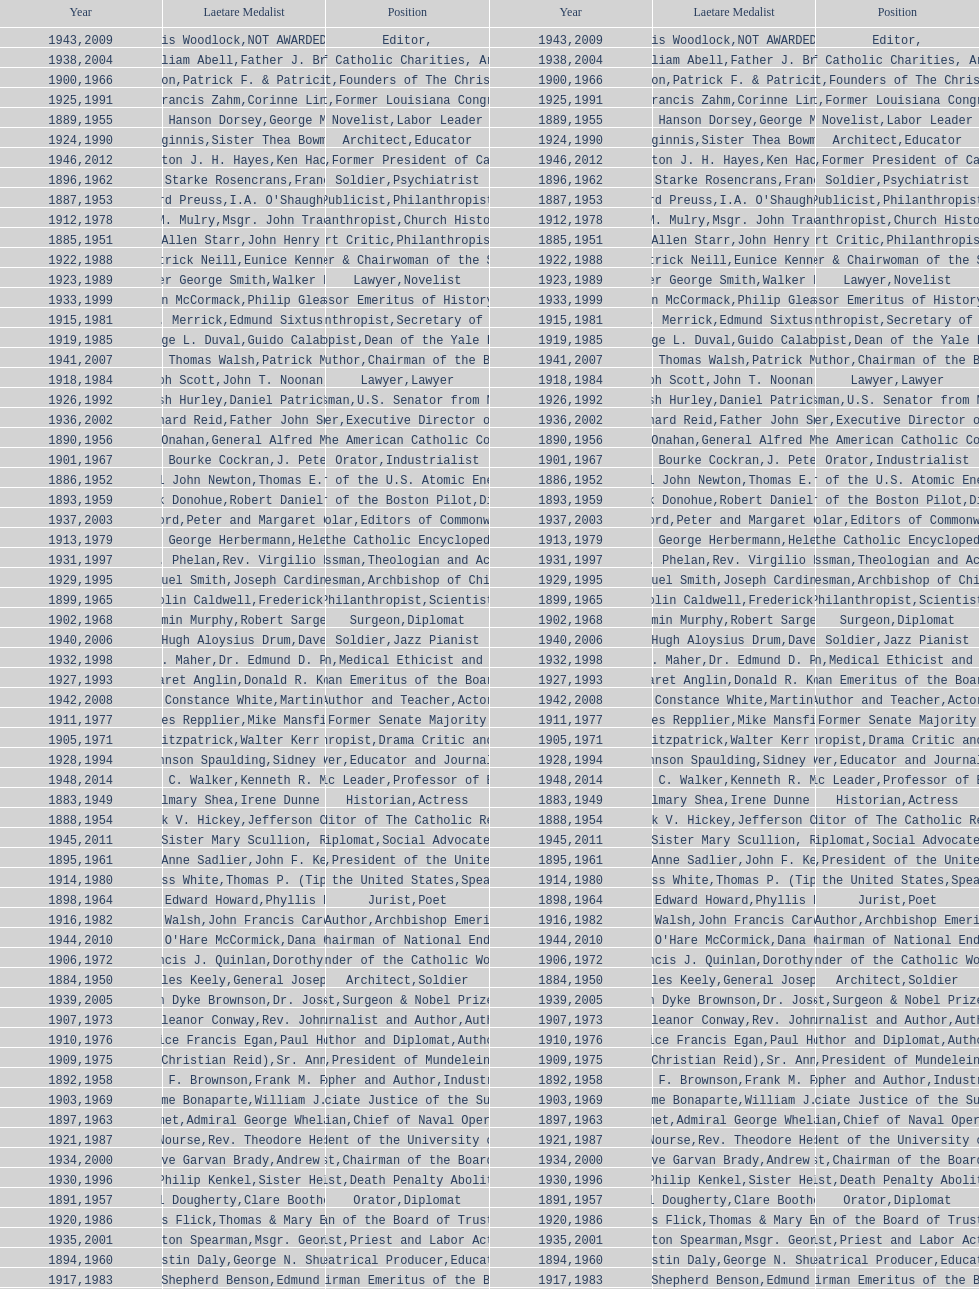How many times does philanthropist appear in the position column on this chart? 9. 